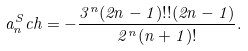Convert formula to latex. <formula><loc_0><loc_0><loc_500><loc_500>a _ { n } ^ { S } c h = - \frac { 3 ^ { n } ( 2 n - 1 ) ! ! ( 2 n - 1 ) } { 2 ^ { n } ( n + 1 ) ! } .</formula> 